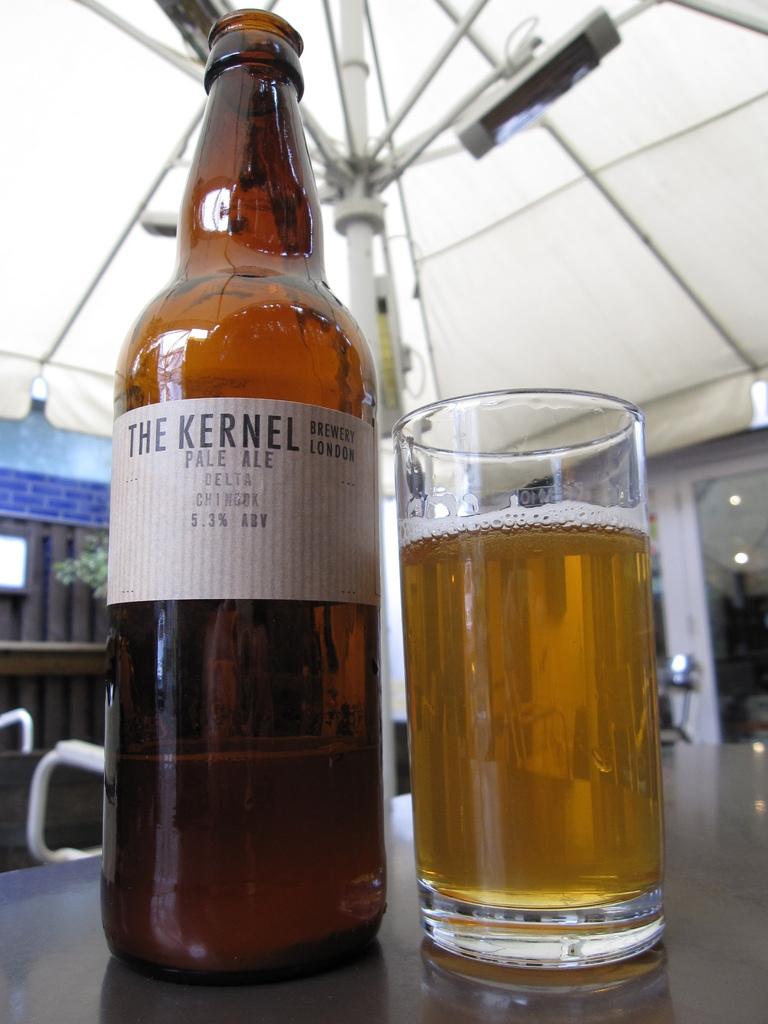What brand of beer?
Provide a short and direct response. The kernel. 